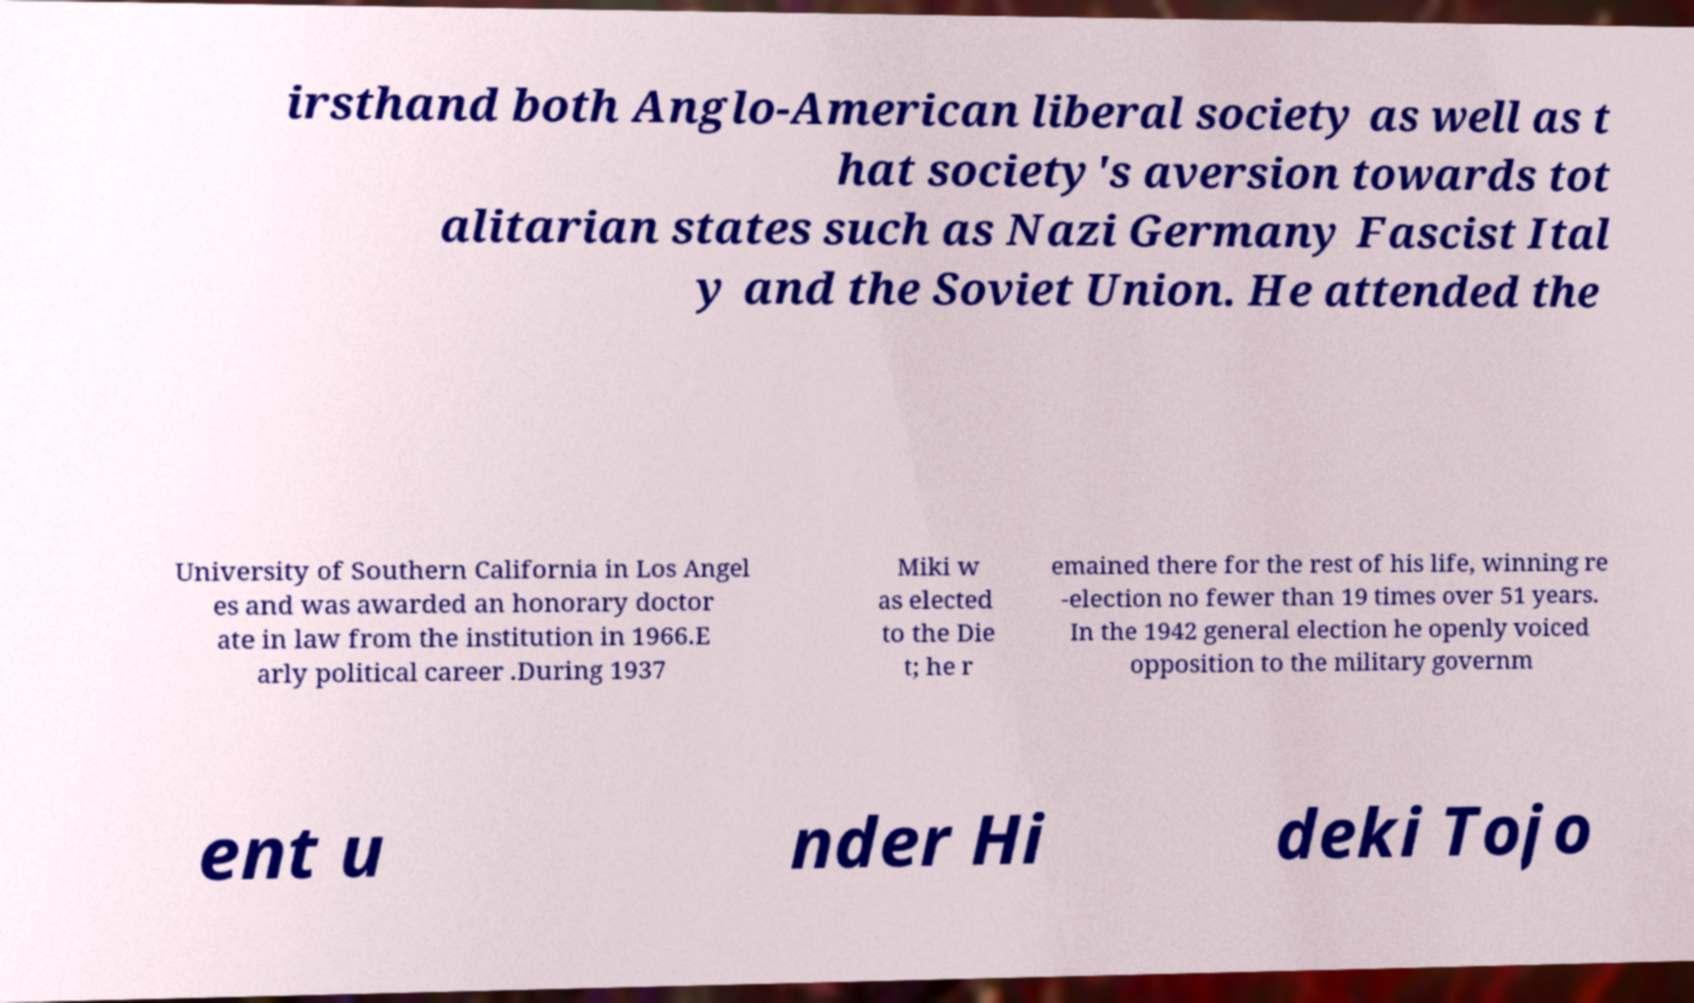I need the written content from this picture converted into text. Can you do that? irsthand both Anglo-American liberal society as well as t hat society's aversion towards tot alitarian states such as Nazi Germany Fascist Ital y and the Soviet Union. He attended the University of Southern California in Los Angel es and was awarded an honorary doctor ate in law from the institution in 1966.E arly political career .During 1937 Miki w as elected to the Die t; he r emained there for the rest of his life, winning re -election no fewer than 19 times over 51 years. In the 1942 general election he openly voiced opposition to the military governm ent u nder Hi deki Tojo 